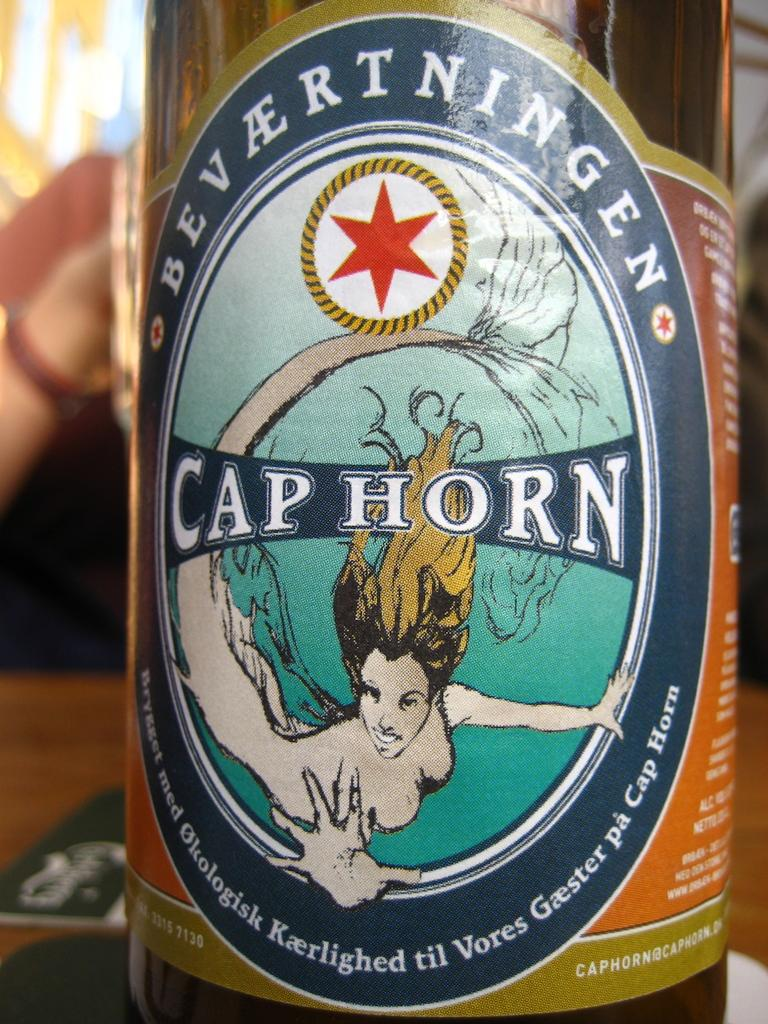What object can be seen in the image? There is a bottle in the image. What feature does the bottle have? The bottle has a label. What is depicted on the label? There is an image of a lady on the label. Are there any words on the label? Yes, there is text on the label. What type of haircut does the lady on the label have? There is no information about the lady's haircut on the label in the image. What time of day is depicted in the image? The image does not depict a specific time of day; it only shows a bottle with a label. 